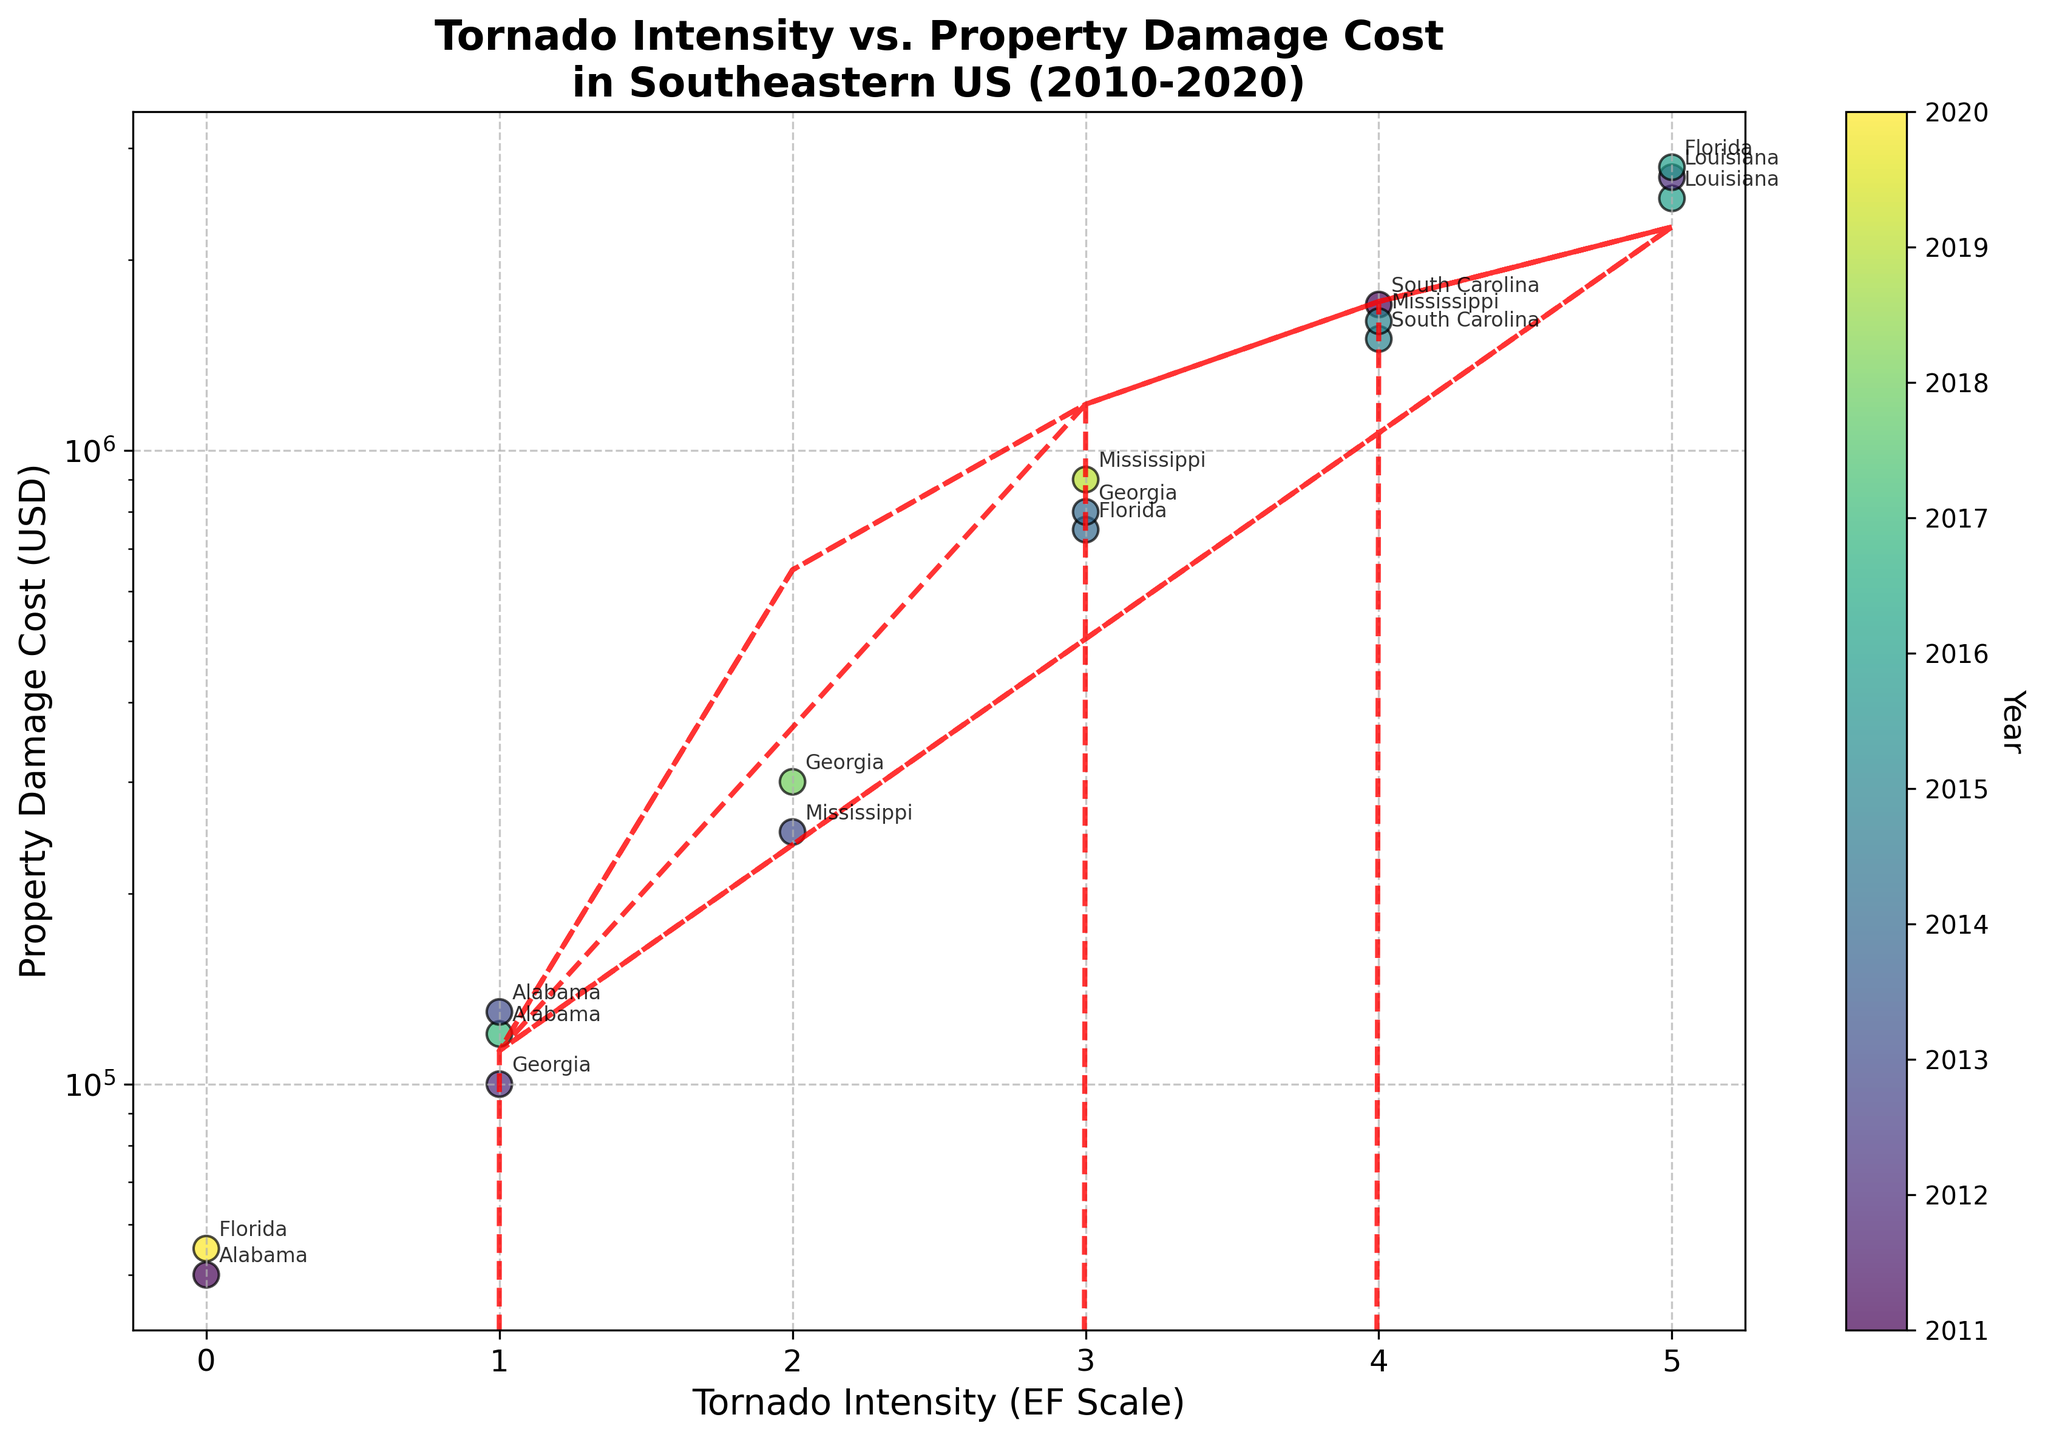What's the title of the figure? The title of the figure is located at the top and often provides a summary of what the plot represents. It should describe the main relationship being visualized.
Answer: Tornado Intensity vs. Property Damage Cost in Southeastern US (2010-2020) What's on the x-axis and y-axis of the figure? The labels on the x-axis and y-axis generally describe the two variables being plotted. By reading these labels, you can determine what data the plot is illustrating.
Answer: Tornado Intensity (EF Scale) on the x-axis and Property Damage Cost (USD) on the y-axis How many data points are there in the scatter plot? To determine the number of data points, count the individual scatter points plotted on the figure.
Answer: 15 What trend does the trend line indicate about the relationship between tornado intensity and property damage costs? The trend line is added to visualize the general direction of the data. It suggests whether there is a positive, negative, or no clear relationship between the two variables.
Answer: Positive correlation What is the highest property damage cost, and which tornado intensity does it correspond to? Locate the highest point on the y-axis and trace it to the corresponding point on the x-axis. The damage cost will be at the peak point of the y-axis, and the EF scale at that point will indicate its tornado intensity.
Answer: \$2,800,000, EF-5 Which year had the highest property damage cost and in which location? The color of the scatter points represents different years. Identify the point with the highest y-value, check its color, and refer to the color bar to find the corresponding year. The annotation near the point reveals the location.
Answer: 2016, Florida How does the property damage cost for EF-3 tornadoes compare between Georgia and Mississippi? Identify the points for EF-3 tornadoes by their EF scale on the x-axis. Compare the y-values (property damage costs) of the points annotated as "Georgia" and "Mississippi."
Answer: Georgia: \$800,000, Mississippi: \$900,000 What changes do you observe in property damage costs for EF-1 tornadoes across different years? Locate the points with EF-1 on the x-axis and observe their y-values. Compare these values and the years they represent using the color.
Answer: Costs range from \$100,000 in 2012 to \$130,000 in 2013 Which EF scale shows the highest variability in property damage costs? Consider the spread of points on the y-axis for each EF scale. A larger spread indicates higher variability.
Answer: EF-5 In which location and year did the least property damage occur, and what was the EF scale? Identify the lowest point on the y-axis, check the EF scale on the x-axis, and refer to the annotation for the location and color for the year.
Answer: Florida, 2020, EF-0 